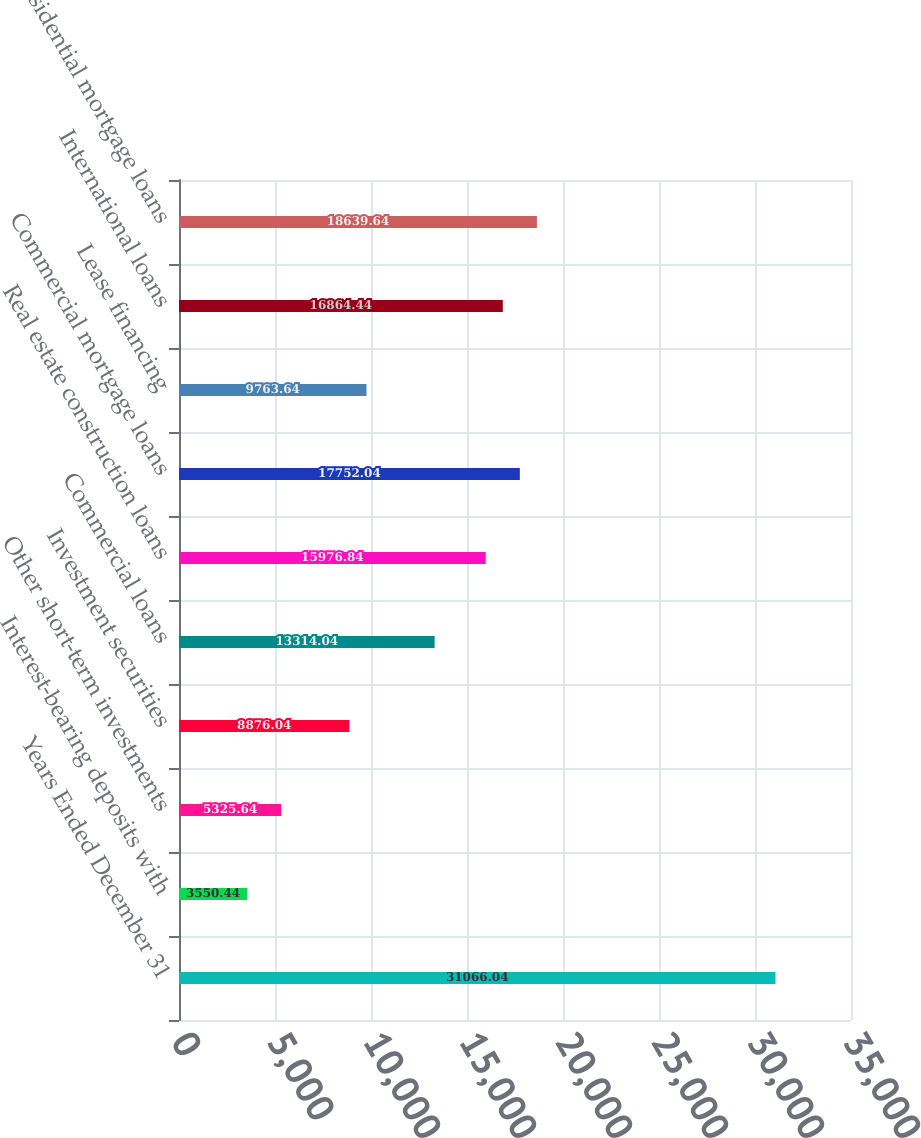Convert chart to OTSL. <chart><loc_0><loc_0><loc_500><loc_500><bar_chart><fcel>Years Ended December 31<fcel>Interest-bearing deposits with<fcel>Other short-term investments<fcel>Investment securities<fcel>Commercial loans<fcel>Real estate construction loans<fcel>Commercial mortgage loans<fcel>Lease financing<fcel>International loans<fcel>Residential mortgage loans<nl><fcel>31066<fcel>3550.44<fcel>5325.64<fcel>8876.04<fcel>13314<fcel>15976.8<fcel>17752<fcel>9763.64<fcel>16864.4<fcel>18639.6<nl></chart> 